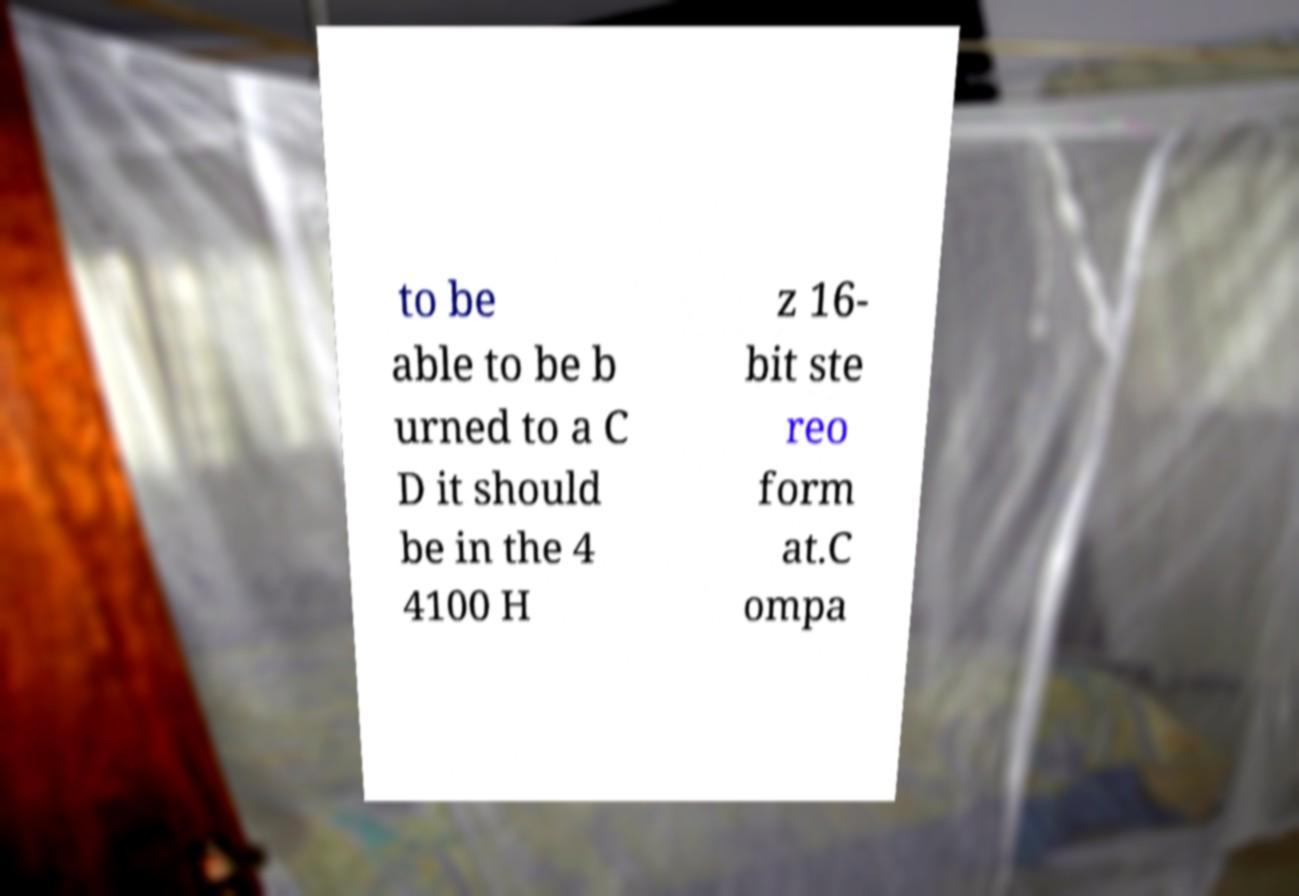Could you extract and type out the text from this image? to be able to be b urned to a C D it should be in the 4 4100 H z 16- bit ste reo form at.C ompa 